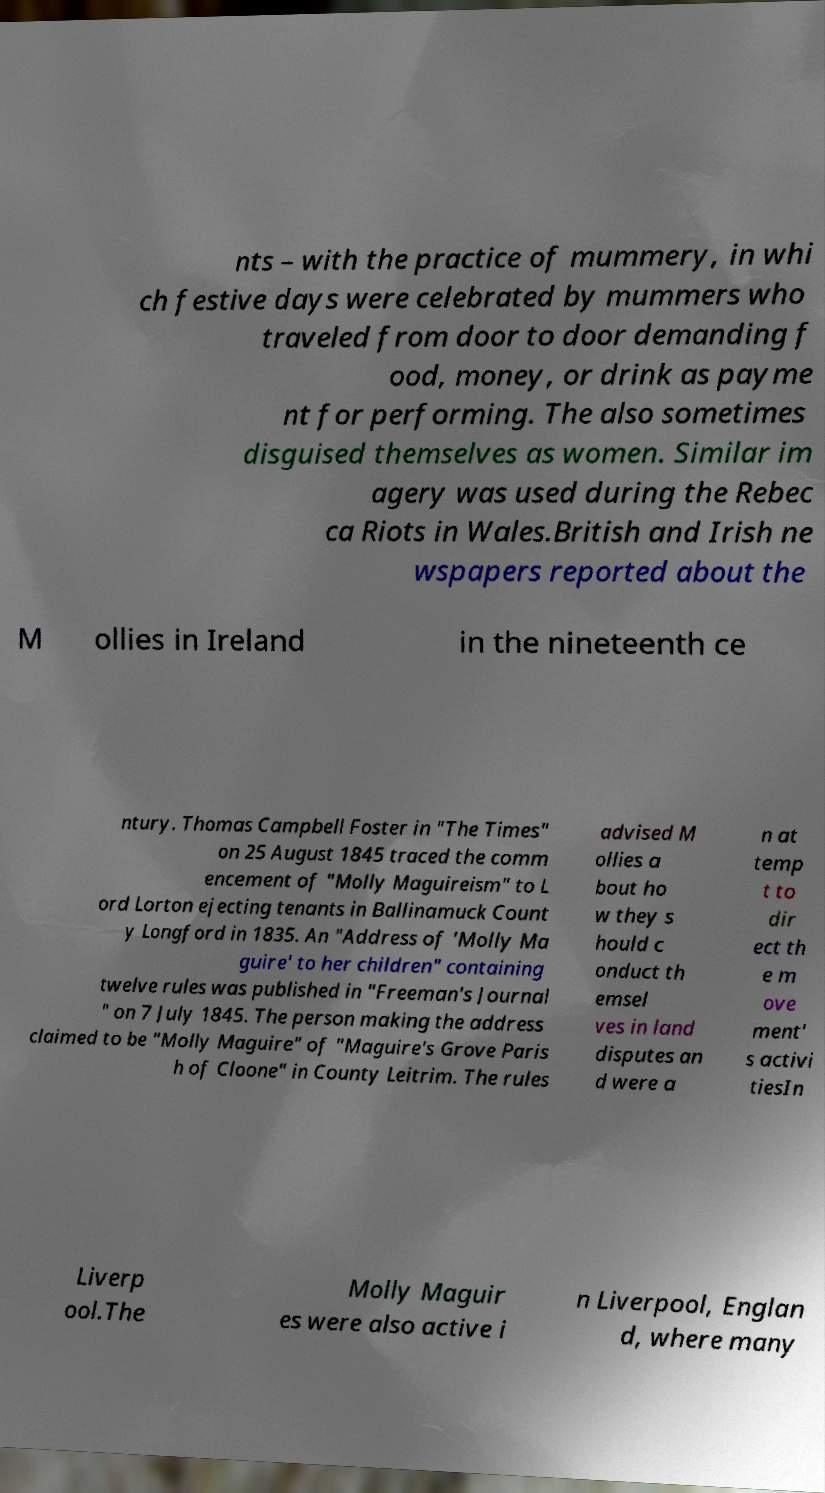For documentation purposes, I need the text within this image transcribed. Could you provide that? nts – with the practice of mummery, in whi ch festive days were celebrated by mummers who traveled from door to door demanding f ood, money, or drink as payme nt for performing. The also sometimes disguised themselves as women. Similar im agery was used during the Rebec ca Riots in Wales.British and Irish ne wspapers reported about the M ollies in Ireland in the nineteenth ce ntury. Thomas Campbell Foster in "The Times" on 25 August 1845 traced the comm encement of "Molly Maguireism" to L ord Lorton ejecting tenants in Ballinamuck Count y Longford in 1835. An "Address of 'Molly Ma guire' to her children" containing twelve rules was published in "Freeman's Journal " on 7 July 1845. The person making the address claimed to be "Molly Maguire" of "Maguire's Grove Paris h of Cloone" in County Leitrim. The rules advised M ollies a bout ho w they s hould c onduct th emsel ves in land disputes an d were a n at temp t to dir ect th e m ove ment' s activi tiesIn Liverp ool.The Molly Maguir es were also active i n Liverpool, Englan d, where many 